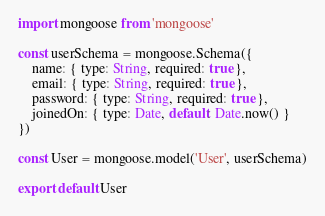<code> <loc_0><loc_0><loc_500><loc_500><_JavaScript_>import mongoose from 'mongoose'

const userSchema = mongoose.Schema({
    name: { type: String, required: true },
    email: { type: String, required: true },
    password: { type: String, required: true },
    joinedOn: { type: Date, default: Date.now() }
})

const User = mongoose.model('User', userSchema)

export default User</code> 